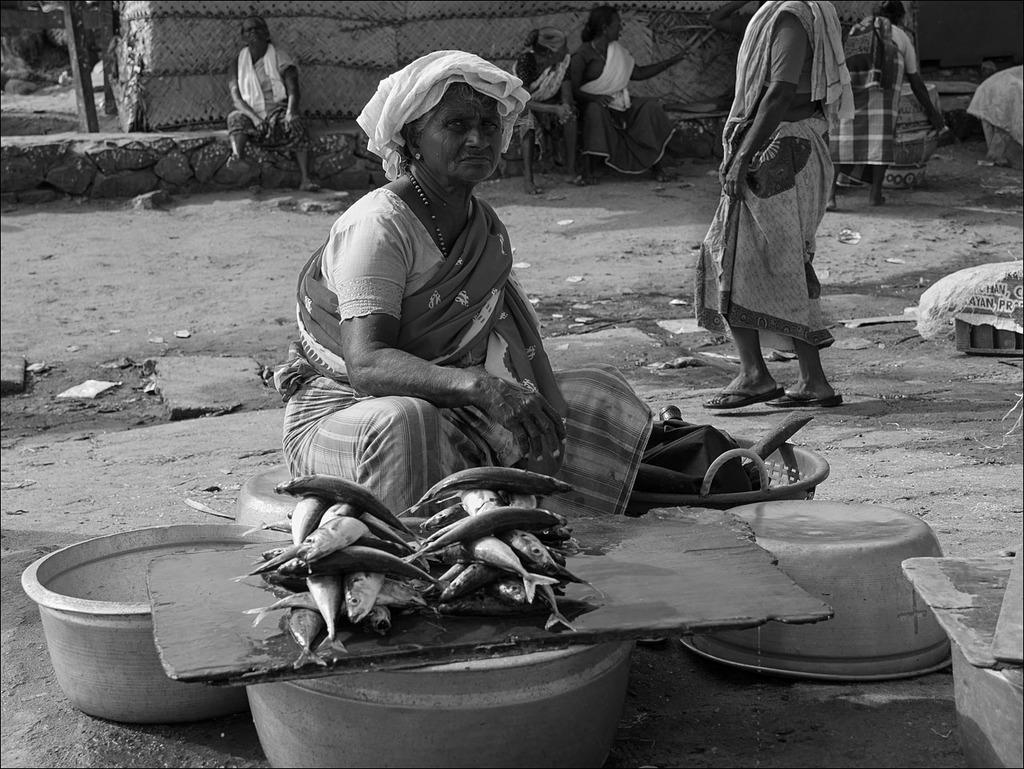What is the woman in the image doing? The woman is sitting in the image. What can be seen in the image besides the woman? There are baskets, a wooden plank, fishes, and other objects in the image. Can you describe the objects in the image? The baskets are likely used for carrying or storing items, the wooden plank may be used for sitting or as a surface, and the fishes are likely caught or being prepared for consumption. What is visible in the background of the image? There are people and a hut in the background of the image, although the hut appears to be truncated. Where is the squirrel sitting in the image? There is no squirrel present in the image. What type of mask is the woman wearing in the image? The woman is not wearing a mask in the image. 